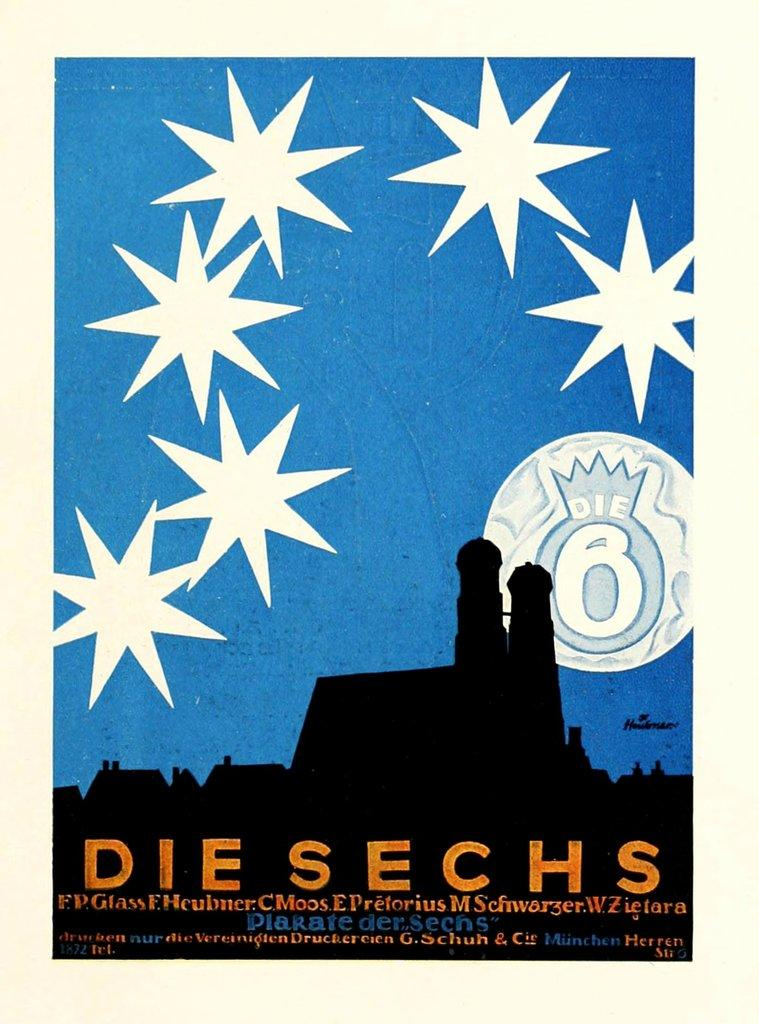Provide a one-sentence caption for the provided image. A poster that says Die Sechs on the bottom of it. 